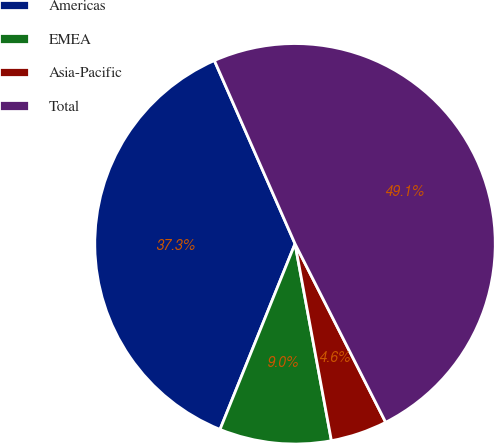Convert chart to OTSL. <chart><loc_0><loc_0><loc_500><loc_500><pie_chart><fcel>Americas<fcel>EMEA<fcel>Asia-Pacific<fcel>Total<nl><fcel>37.29%<fcel>9.02%<fcel>4.57%<fcel>49.12%<nl></chart> 